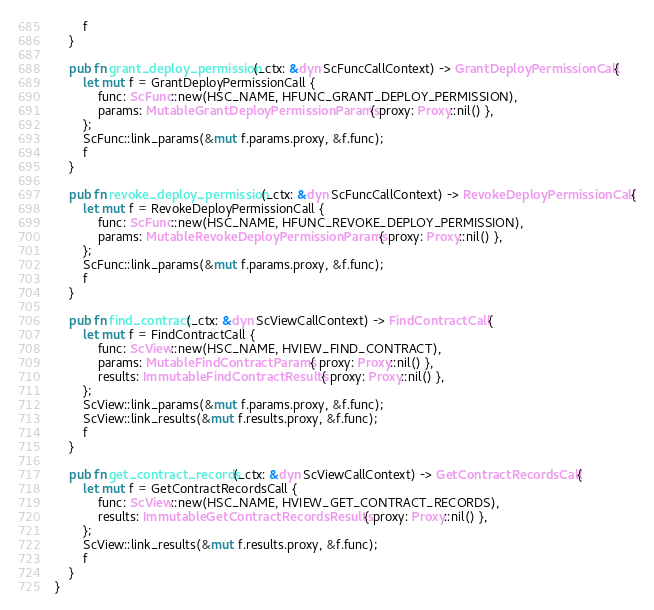Convert code to text. <code><loc_0><loc_0><loc_500><loc_500><_Rust_>        f
    }

    pub fn grant_deploy_permission(_ctx: &dyn ScFuncCallContext) -> GrantDeployPermissionCall {
        let mut f = GrantDeployPermissionCall {
            func: ScFunc::new(HSC_NAME, HFUNC_GRANT_DEPLOY_PERMISSION),
            params: MutableGrantDeployPermissionParams { proxy: Proxy::nil() },
        };
        ScFunc::link_params(&mut f.params.proxy, &f.func);
        f
    }

    pub fn revoke_deploy_permission(_ctx: &dyn ScFuncCallContext) -> RevokeDeployPermissionCall {
        let mut f = RevokeDeployPermissionCall {
            func: ScFunc::new(HSC_NAME, HFUNC_REVOKE_DEPLOY_PERMISSION),
            params: MutableRevokeDeployPermissionParams { proxy: Proxy::nil() },
        };
        ScFunc::link_params(&mut f.params.proxy, &f.func);
        f
    }

    pub fn find_contract(_ctx: &dyn ScViewCallContext) -> FindContractCall {
        let mut f = FindContractCall {
            func: ScView::new(HSC_NAME, HVIEW_FIND_CONTRACT),
            params: MutableFindContractParams { proxy: Proxy::nil() },
            results: ImmutableFindContractResults { proxy: Proxy::nil() },
        };
        ScView::link_params(&mut f.params.proxy, &f.func);
        ScView::link_results(&mut f.results.proxy, &f.func);
        f
    }

    pub fn get_contract_records(_ctx: &dyn ScViewCallContext) -> GetContractRecordsCall {
        let mut f = GetContractRecordsCall {
            func: ScView::new(HSC_NAME, HVIEW_GET_CONTRACT_RECORDS),
            results: ImmutableGetContractRecordsResults { proxy: Proxy::nil() },
        };
        ScView::link_results(&mut f.results.proxy, &f.func);
        f
    }
}
</code> 